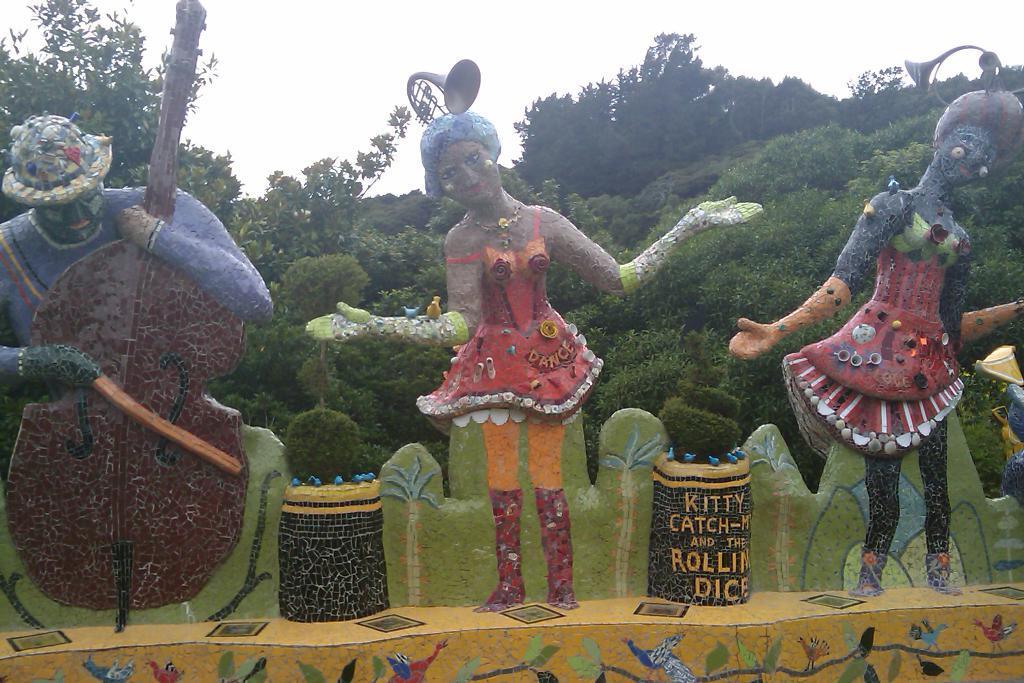Could you give a brief overview of what you see in this image? In this image, we can see sculptures and paintings. In the background, there are plants, trees and the sky. 